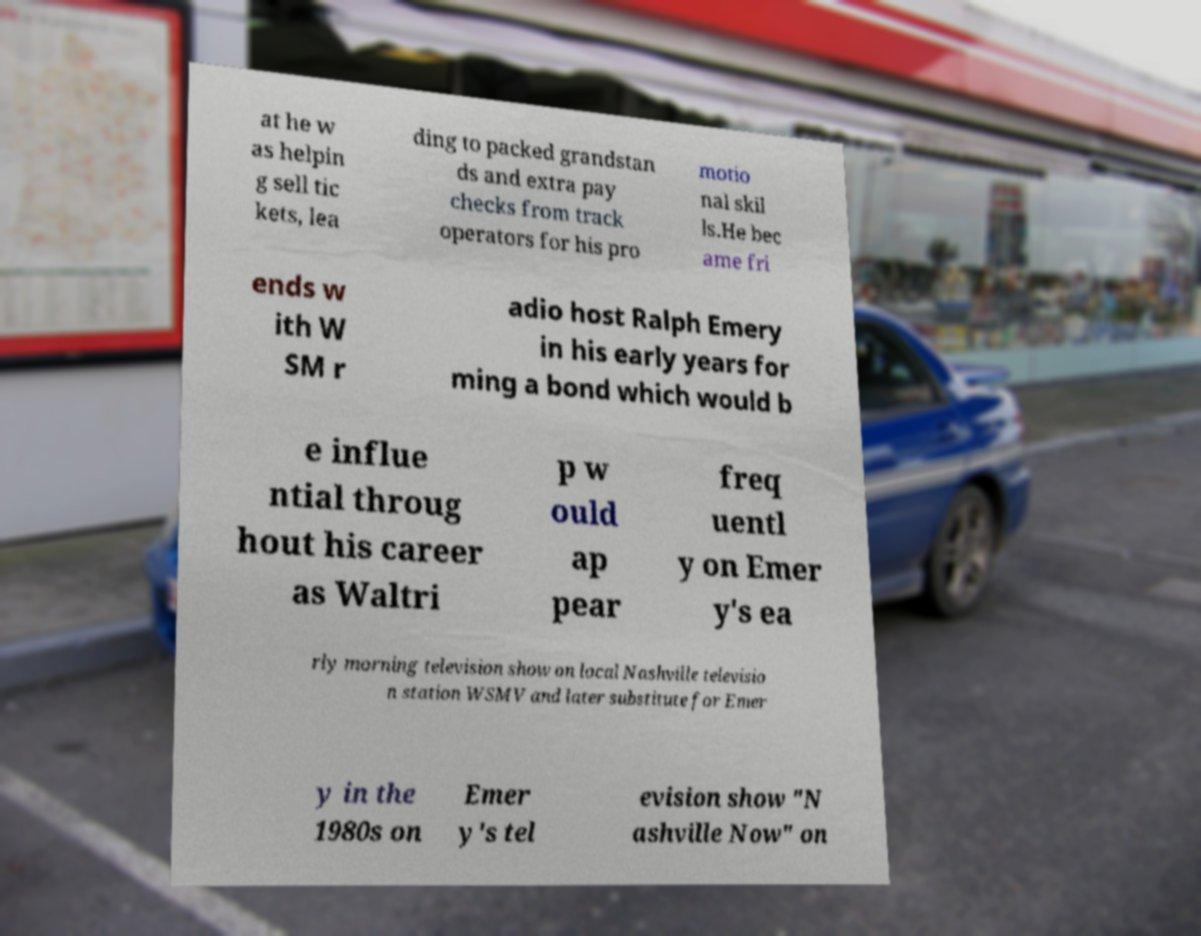Can you read and provide the text displayed in the image?This photo seems to have some interesting text. Can you extract and type it out for me? at he w as helpin g sell tic kets, lea ding to packed grandstan ds and extra pay checks from track operators for his pro motio nal skil ls.He bec ame fri ends w ith W SM r adio host Ralph Emery in his early years for ming a bond which would b e influe ntial throug hout his career as Waltri p w ould ap pear freq uentl y on Emer y's ea rly morning television show on local Nashville televisio n station WSMV and later substitute for Emer y in the 1980s on Emer y's tel evision show "N ashville Now" on 